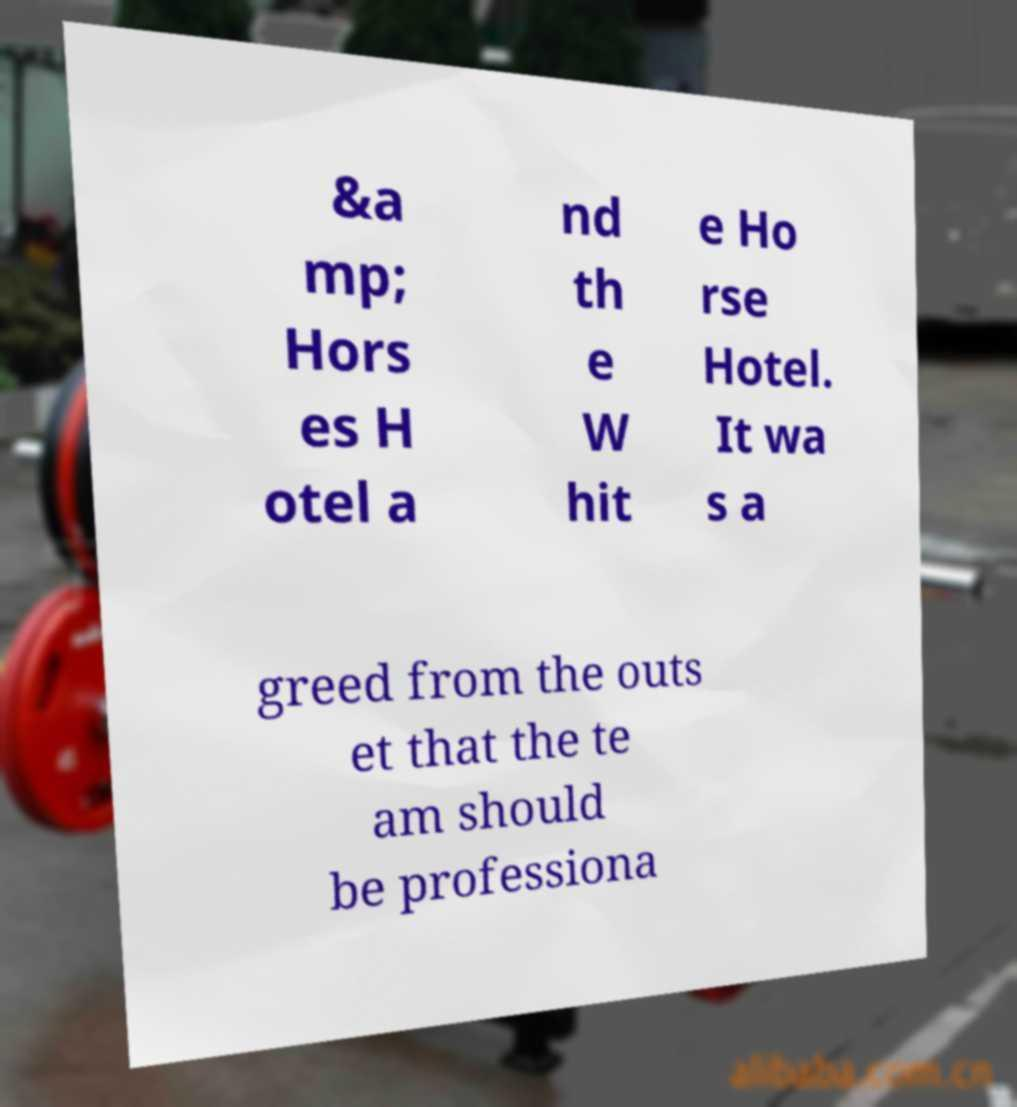Can you accurately transcribe the text from the provided image for me? &a mp; Hors es H otel a nd th e W hit e Ho rse Hotel. It wa s a greed from the outs et that the te am should be professiona 